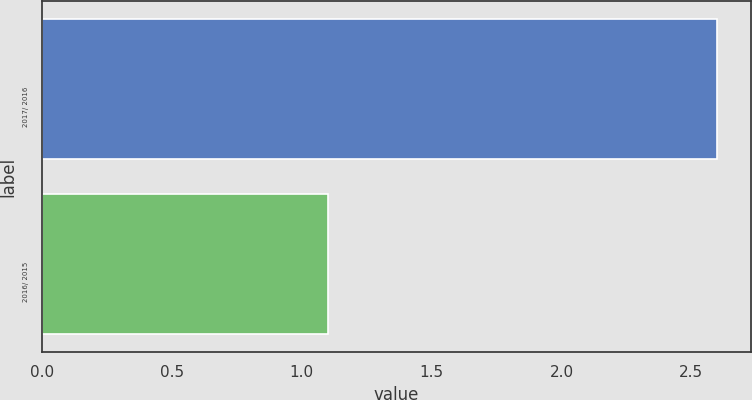Convert chart to OTSL. <chart><loc_0><loc_0><loc_500><loc_500><bar_chart><fcel>2017/ 2016<fcel>2016/ 2015<nl><fcel>2.6<fcel>1.1<nl></chart> 